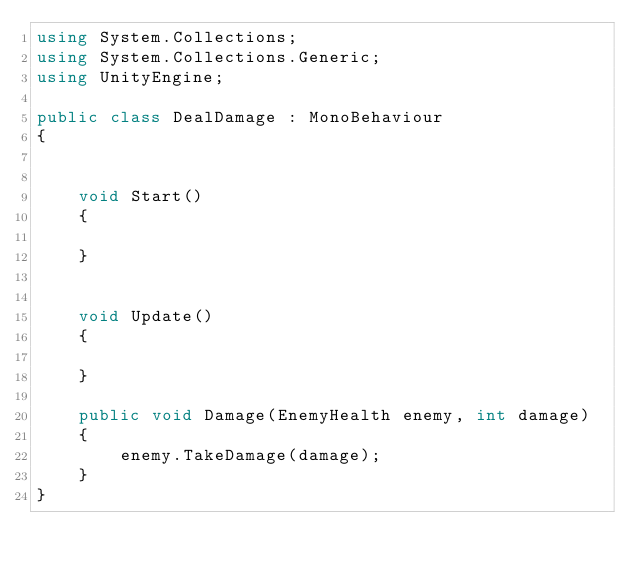Convert code to text. <code><loc_0><loc_0><loc_500><loc_500><_C#_>using System.Collections;
using System.Collections.Generic;
using UnityEngine;

public class DealDamage : MonoBehaviour
{
    

    void Start()
    {
        
    }

    
    void Update()
    {
        
    }

    public void Damage(EnemyHealth enemy, int damage)
    {
        enemy.TakeDamage(damage);
    }
}
</code> 